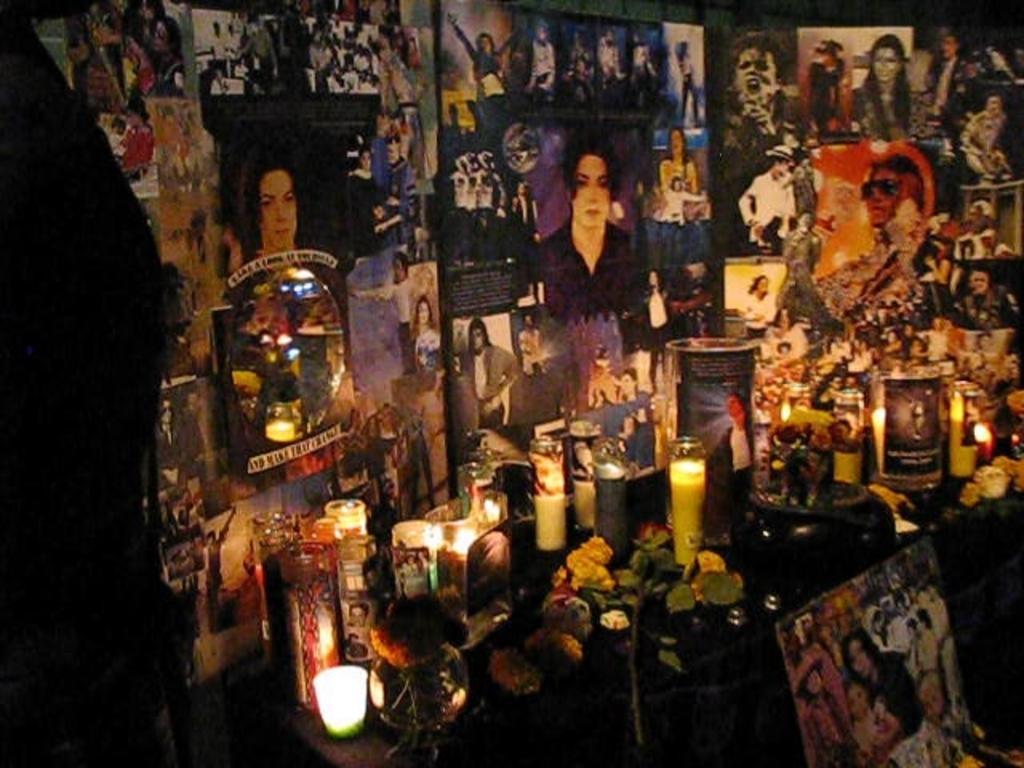How would you summarize this image in a sentence or two? In this image I can see a table which is black in color and on the table I can see few candles, few flowers which are yellow in color, few photo frames and few other objects. In the background I can see number of posters of a person are attached to the wall. 